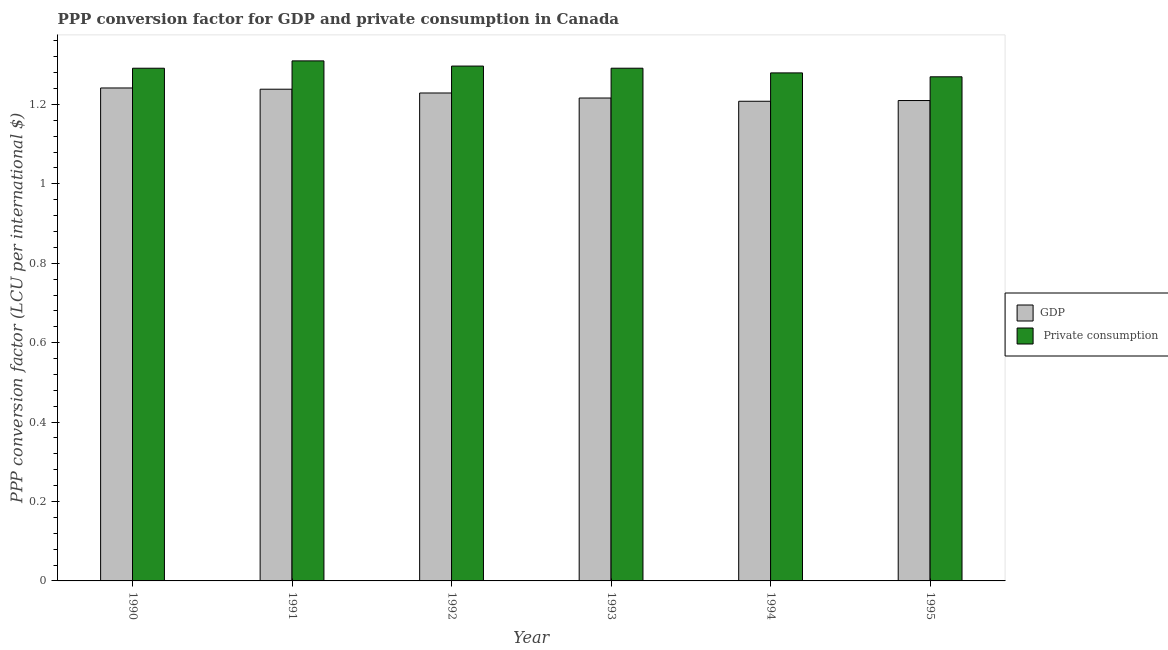How many different coloured bars are there?
Your answer should be compact. 2. How many groups of bars are there?
Ensure brevity in your answer.  6. Are the number of bars per tick equal to the number of legend labels?
Make the answer very short. Yes. Are the number of bars on each tick of the X-axis equal?
Keep it short and to the point. Yes. How many bars are there on the 2nd tick from the right?
Your answer should be very brief. 2. What is the label of the 4th group of bars from the left?
Ensure brevity in your answer.  1993. In how many cases, is the number of bars for a given year not equal to the number of legend labels?
Offer a terse response. 0. What is the ppp conversion factor for private consumption in 1993?
Offer a very short reply. 1.29. Across all years, what is the maximum ppp conversion factor for private consumption?
Make the answer very short. 1.31. Across all years, what is the minimum ppp conversion factor for private consumption?
Your answer should be compact. 1.27. What is the total ppp conversion factor for private consumption in the graph?
Your response must be concise. 7.74. What is the difference between the ppp conversion factor for private consumption in 1992 and that in 1995?
Keep it short and to the point. 0.03. What is the difference between the ppp conversion factor for private consumption in 1990 and the ppp conversion factor for gdp in 1994?
Your response must be concise. 0.01. What is the average ppp conversion factor for private consumption per year?
Keep it short and to the point. 1.29. In the year 1993, what is the difference between the ppp conversion factor for gdp and ppp conversion factor for private consumption?
Provide a succinct answer. 0. In how many years, is the ppp conversion factor for gdp greater than 0.32 LCU?
Keep it short and to the point. 6. What is the ratio of the ppp conversion factor for gdp in 1990 to that in 1992?
Ensure brevity in your answer.  1.01. What is the difference between the highest and the second highest ppp conversion factor for private consumption?
Provide a succinct answer. 0.01. What is the difference between the highest and the lowest ppp conversion factor for gdp?
Your response must be concise. 0.03. In how many years, is the ppp conversion factor for gdp greater than the average ppp conversion factor for gdp taken over all years?
Offer a very short reply. 3. Is the sum of the ppp conversion factor for private consumption in 1990 and 1995 greater than the maximum ppp conversion factor for gdp across all years?
Your answer should be compact. Yes. What does the 1st bar from the left in 1990 represents?
Provide a succinct answer. GDP. What does the 1st bar from the right in 1995 represents?
Your response must be concise.  Private consumption. What is the difference between two consecutive major ticks on the Y-axis?
Provide a short and direct response. 0.2. Are the values on the major ticks of Y-axis written in scientific E-notation?
Offer a terse response. No. Where does the legend appear in the graph?
Your answer should be compact. Center right. How many legend labels are there?
Make the answer very short. 2. How are the legend labels stacked?
Your answer should be compact. Vertical. What is the title of the graph?
Provide a succinct answer. PPP conversion factor for GDP and private consumption in Canada. Does "Non-resident workers" appear as one of the legend labels in the graph?
Keep it short and to the point. No. What is the label or title of the Y-axis?
Make the answer very short. PPP conversion factor (LCU per international $). What is the PPP conversion factor (LCU per international $) in GDP in 1990?
Keep it short and to the point. 1.24. What is the PPP conversion factor (LCU per international $) of  Private consumption in 1990?
Make the answer very short. 1.29. What is the PPP conversion factor (LCU per international $) of GDP in 1991?
Ensure brevity in your answer.  1.24. What is the PPP conversion factor (LCU per international $) in  Private consumption in 1991?
Provide a succinct answer. 1.31. What is the PPP conversion factor (LCU per international $) of GDP in 1992?
Your answer should be compact. 1.23. What is the PPP conversion factor (LCU per international $) in  Private consumption in 1992?
Your answer should be compact. 1.3. What is the PPP conversion factor (LCU per international $) in GDP in 1993?
Provide a short and direct response. 1.22. What is the PPP conversion factor (LCU per international $) of  Private consumption in 1993?
Offer a terse response. 1.29. What is the PPP conversion factor (LCU per international $) in GDP in 1994?
Make the answer very short. 1.21. What is the PPP conversion factor (LCU per international $) in  Private consumption in 1994?
Your response must be concise. 1.28. What is the PPP conversion factor (LCU per international $) in GDP in 1995?
Keep it short and to the point. 1.21. What is the PPP conversion factor (LCU per international $) in  Private consumption in 1995?
Provide a short and direct response. 1.27. Across all years, what is the maximum PPP conversion factor (LCU per international $) of GDP?
Your answer should be compact. 1.24. Across all years, what is the maximum PPP conversion factor (LCU per international $) of  Private consumption?
Offer a terse response. 1.31. Across all years, what is the minimum PPP conversion factor (LCU per international $) of GDP?
Give a very brief answer. 1.21. Across all years, what is the minimum PPP conversion factor (LCU per international $) in  Private consumption?
Provide a short and direct response. 1.27. What is the total PPP conversion factor (LCU per international $) in GDP in the graph?
Your answer should be very brief. 7.34. What is the total PPP conversion factor (LCU per international $) of  Private consumption in the graph?
Keep it short and to the point. 7.74. What is the difference between the PPP conversion factor (LCU per international $) in GDP in 1990 and that in 1991?
Make the answer very short. 0. What is the difference between the PPP conversion factor (LCU per international $) in  Private consumption in 1990 and that in 1991?
Your answer should be compact. -0.02. What is the difference between the PPP conversion factor (LCU per international $) in GDP in 1990 and that in 1992?
Make the answer very short. 0.01. What is the difference between the PPP conversion factor (LCU per international $) in  Private consumption in 1990 and that in 1992?
Make the answer very short. -0.01. What is the difference between the PPP conversion factor (LCU per international $) in GDP in 1990 and that in 1993?
Provide a short and direct response. 0.03. What is the difference between the PPP conversion factor (LCU per international $) of  Private consumption in 1990 and that in 1993?
Your response must be concise. -0. What is the difference between the PPP conversion factor (LCU per international $) of GDP in 1990 and that in 1994?
Your response must be concise. 0.03. What is the difference between the PPP conversion factor (LCU per international $) of  Private consumption in 1990 and that in 1994?
Provide a succinct answer. 0.01. What is the difference between the PPP conversion factor (LCU per international $) of GDP in 1990 and that in 1995?
Provide a succinct answer. 0.03. What is the difference between the PPP conversion factor (LCU per international $) of  Private consumption in 1990 and that in 1995?
Your answer should be compact. 0.02. What is the difference between the PPP conversion factor (LCU per international $) of GDP in 1991 and that in 1992?
Provide a short and direct response. 0.01. What is the difference between the PPP conversion factor (LCU per international $) in  Private consumption in 1991 and that in 1992?
Give a very brief answer. 0.01. What is the difference between the PPP conversion factor (LCU per international $) in GDP in 1991 and that in 1993?
Ensure brevity in your answer.  0.02. What is the difference between the PPP conversion factor (LCU per international $) of  Private consumption in 1991 and that in 1993?
Provide a succinct answer. 0.02. What is the difference between the PPP conversion factor (LCU per international $) of GDP in 1991 and that in 1994?
Provide a succinct answer. 0.03. What is the difference between the PPP conversion factor (LCU per international $) of  Private consumption in 1991 and that in 1994?
Provide a succinct answer. 0.03. What is the difference between the PPP conversion factor (LCU per international $) of GDP in 1991 and that in 1995?
Give a very brief answer. 0.03. What is the difference between the PPP conversion factor (LCU per international $) in  Private consumption in 1991 and that in 1995?
Provide a succinct answer. 0.04. What is the difference between the PPP conversion factor (LCU per international $) in GDP in 1992 and that in 1993?
Your answer should be compact. 0.01. What is the difference between the PPP conversion factor (LCU per international $) of  Private consumption in 1992 and that in 1993?
Provide a succinct answer. 0.01. What is the difference between the PPP conversion factor (LCU per international $) of GDP in 1992 and that in 1994?
Provide a succinct answer. 0.02. What is the difference between the PPP conversion factor (LCU per international $) of  Private consumption in 1992 and that in 1994?
Your answer should be very brief. 0.02. What is the difference between the PPP conversion factor (LCU per international $) in GDP in 1992 and that in 1995?
Your answer should be compact. 0.02. What is the difference between the PPP conversion factor (LCU per international $) in  Private consumption in 1992 and that in 1995?
Your answer should be compact. 0.03. What is the difference between the PPP conversion factor (LCU per international $) in GDP in 1993 and that in 1994?
Your answer should be very brief. 0.01. What is the difference between the PPP conversion factor (LCU per international $) of  Private consumption in 1993 and that in 1994?
Provide a succinct answer. 0.01. What is the difference between the PPP conversion factor (LCU per international $) of GDP in 1993 and that in 1995?
Your answer should be very brief. 0.01. What is the difference between the PPP conversion factor (LCU per international $) in  Private consumption in 1993 and that in 1995?
Keep it short and to the point. 0.02. What is the difference between the PPP conversion factor (LCU per international $) in GDP in 1994 and that in 1995?
Ensure brevity in your answer.  -0. What is the difference between the PPP conversion factor (LCU per international $) of  Private consumption in 1994 and that in 1995?
Give a very brief answer. 0.01. What is the difference between the PPP conversion factor (LCU per international $) of GDP in 1990 and the PPP conversion factor (LCU per international $) of  Private consumption in 1991?
Offer a very short reply. -0.07. What is the difference between the PPP conversion factor (LCU per international $) in GDP in 1990 and the PPP conversion factor (LCU per international $) in  Private consumption in 1992?
Make the answer very short. -0.06. What is the difference between the PPP conversion factor (LCU per international $) of GDP in 1990 and the PPP conversion factor (LCU per international $) of  Private consumption in 1993?
Provide a succinct answer. -0.05. What is the difference between the PPP conversion factor (LCU per international $) in GDP in 1990 and the PPP conversion factor (LCU per international $) in  Private consumption in 1994?
Offer a very short reply. -0.04. What is the difference between the PPP conversion factor (LCU per international $) in GDP in 1990 and the PPP conversion factor (LCU per international $) in  Private consumption in 1995?
Keep it short and to the point. -0.03. What is the difference between the PPP conversion factor (LCU per international $) of GDP in 1991 and the PPP conversion factor (LCU per international $) of  Private consumption in 1992?
Your answer should be very brief. -0.06. What is the difference between the PPP conversion factor (LCU per international $) of GDP in 1991 and the PPP conversion factor (LCU per international $) of  Private consumption in 1993?
Keep it short and to the point. -0.05. What is the difference between the PPP conversion factor (LCU per international $) of GDP in 1991 and the PPP conversion factor (LCU per international $) of  Private consumption in 1994?
Offer a terse response. -0.04. What is the difference between the PPP conversion factor (LCU per international $) in GDP in 1991 and the PPP conversion factor (LCU per international $) in  Private consumption in 1995?
Your answer should be very brief. -0.03. What is the difference between the PPP conversion factor (LCU per international $) of GDP in 1992 and the PPP conversion factor (LCU per international $) of  Private consumption in 1993?
Ensure brevity in your answer.  -0.06. What is the difference between the PPP conversion factor (LCU per international $) of GDP in 1992 and the PPP conversion factor (LCU per international $) of  Private consumption in 1994?
Keep it short and to the point. -0.05. What is the difference between the PPP conversion factor (LCU per international $) of GDP in 1992 and the PPP conversion factor (LCU per international $) of  Private consumption in 1995?
Ensure brevity in your answer.  -0.04. What is the difference between the PPP conversion factor (LCU per international $) in GDP in 1993 and the PPP conversion factor (LCU per international $) in  Private consumption in 1994?
Your answer should be compact. -0.06. What is the difference between the PPP conversion factor (LCU per international $) in GDP in 1993 and the PPP conversion factor (LCU per international $) in  Private consumption in 1995?
Offer a very short reply. -0.05. What is the difference between the PPP conversion factor (LCU per international $) of GDP in 1994 and the PPP conversion factor (LCU per international $) of  Private consumption in 1995?
Your answer should be compact. -0.06. What is the average PPP conversion factor (LCU per international $) in GDP per year?
Provide a short and direct response. 1.22. What is the average PPP conversion factor (LCU per international $) of  Private consumption per year?
Keep it short and to the point. 1.29. In the year 1990, what is the difference between the PPP conversion factor (LCU per international $) of GDP and PPP conversion factor (LCU per international $) of  Private consumption?
Keep it short and to the point. -0.05. In the year 1991, what is the difference between the PPP conversion factor (LCU per international $) in GDP and PPP conversion factor (LCU per international $) in  Private consumption?
Your response must be concise. -0.07. In the year 1992, what is the difference between the PPP conversion factor (LCU per international $) of GDP and PPP conversion factor (LCU per international $) of  Private consumption?
Provide a short and direct response. -0.07. In the year 1993, what is the difference between the PPP conversion factor (LCU per international $) in GDP and PPP conversion factor (LCU per international $) in  Private consumption?
Your answer should be very brief. -0.08. In the year 1994, what is the difference between the PPP conversion factor (LCU per international $) in GDP and PPP conversion factor (LCU per international $) in  Private consumption?
Provide a succinct answer. -0.07. In the year 1995, what is the difference between the PPP conversion factor (LCU per international $) of GDP and PPP conversion factor (LCU per international $) of  Private consumption?
Your answer should be very brief. -0.06. What is the ratio of the PPP conversion factor (LCU per international $) of  Private consumption in 1990 to that in 1991?
Offer a terse response. 0.99. What is the ratio of the PPP conversion factor (LCU per international $) of GDP in 1990 to that in 1992?
Give a very brief answer. 1.01. What is the ratio of the PPP conversion factor (LCU per international $) of GDP in 1990 to that in 1993?
Keep it short and to the point. 1.02. What is the ratio of the PPP conversion factor (LCU per international $) in GDP in 1990 to that in 1994?
Offer a very short reply. 1.03. What is the ratio of the PPP conversion factor (LCU per international $) of  Private consumption in 1990 to that in 1994?
Your answer should be very brief. 1.01. What is the ratio of the PPP conversion factor (LCU per international $) of GDP in 1990 to that in 1995?
Your answer should be very brief. 1.03. What is the ratio of the PPP conversion factor (LCU per international $) of GDP in 1991 to that in 1992?
Offer a very short reply. 1.01. What is the ratio of the PPP conversion factor (LCU per international $) of  Private consumption in 1991 to that in 1992?
Your response must be concise. 1.01. What is the ratio of the PPP conversion factor (LCU per international $) in GDP in 1991 to that in 1993?
Offer a terse response. 1.02. What is the ratio of the PPP conversion factor (LCU per international $) of  Private consumption in 1991 to that in 1993?
Make the answer very short. 1.01. What is the ratio of the PPP conversion factor (LCU per international $) in GDP in 1991 to that in 1994?
Your answer should be compact. 1.03. What is the ratio of the PPP conversion factor (LCU per international $) of  Private consumption in 1991 to that in 1994?
Make the answer very short. 1.02. What is the ratio of the PPP conversion factor (LCU per international $) in GDP in 1991 to that in 1995?
Give a very brief answer. 1.02. What is the ratio of the PPP conversion factor (LCU per international $) of  Private consumption in 1991 to that in 1995?
Provide a succinct answer. 1.03. What is the ratio of the PPP conversion factor (LCU per international $) in GDP in 1992 to that in 1993?
Your response must be concise. 1.01. What is the ratio of the PPP conversion factor (LCU per international $) of  Private consumption in 1992 to that in 1993?
Offer a very short reply. 1. What is the ratio of the PPP conversion factor (LCU per international $) of GDP in 1992 to that in 1994?
Keep it short and to the point. 1.02. What is the ratio of the PPP conversion factor (LCU per international $) of  Private consumption in 1992 to that in 1994?
Your answer should be very brief. 1.01. What is the ratio of the PPP conversion factor (LCU per international $) in GDP in 1992 to that in 1995?
Give a very brief answer. 1.02. What is the ratio of the PPP conversion factor (LCU per international $) in  Private consumption in 1992 to that in 1995?
Your answer should be compact. 1.02. What is the ratio of the PPP conversion factor (LCU per international $) in  Private consumption in 1993 to that in 1994?
Offer a very short reply. 1.01. What is the ratio of the PPP conversion factor (LCU per international $) of GDP in 1993 to that in 1995?
Your answer should be compact. 1.01. What is the ratio of the PPP conversion factor (LCU per international $) of  Private consumption in 1994 to that in 1995?
Offer a terse response. 1.01. What is the difference between the highest and the second highest PPP conversion factor (LCU per international $) of GDP?
Your response must be concise. 0. What is the difference between the highest and the second highest PPP conversion factor (LCU per international $) in  Private consumption?
Offer a terse response. 0.01. What is the difference between the highest and the lowest PPP conversion factor (LCU per international $) in GDP?
Provide a succinct answer. 0.03. What is the difference between the highest and the lowest PPP conversion factor (LCU per international $) in  Private consumption?
Your response must be concise. 0.04. 